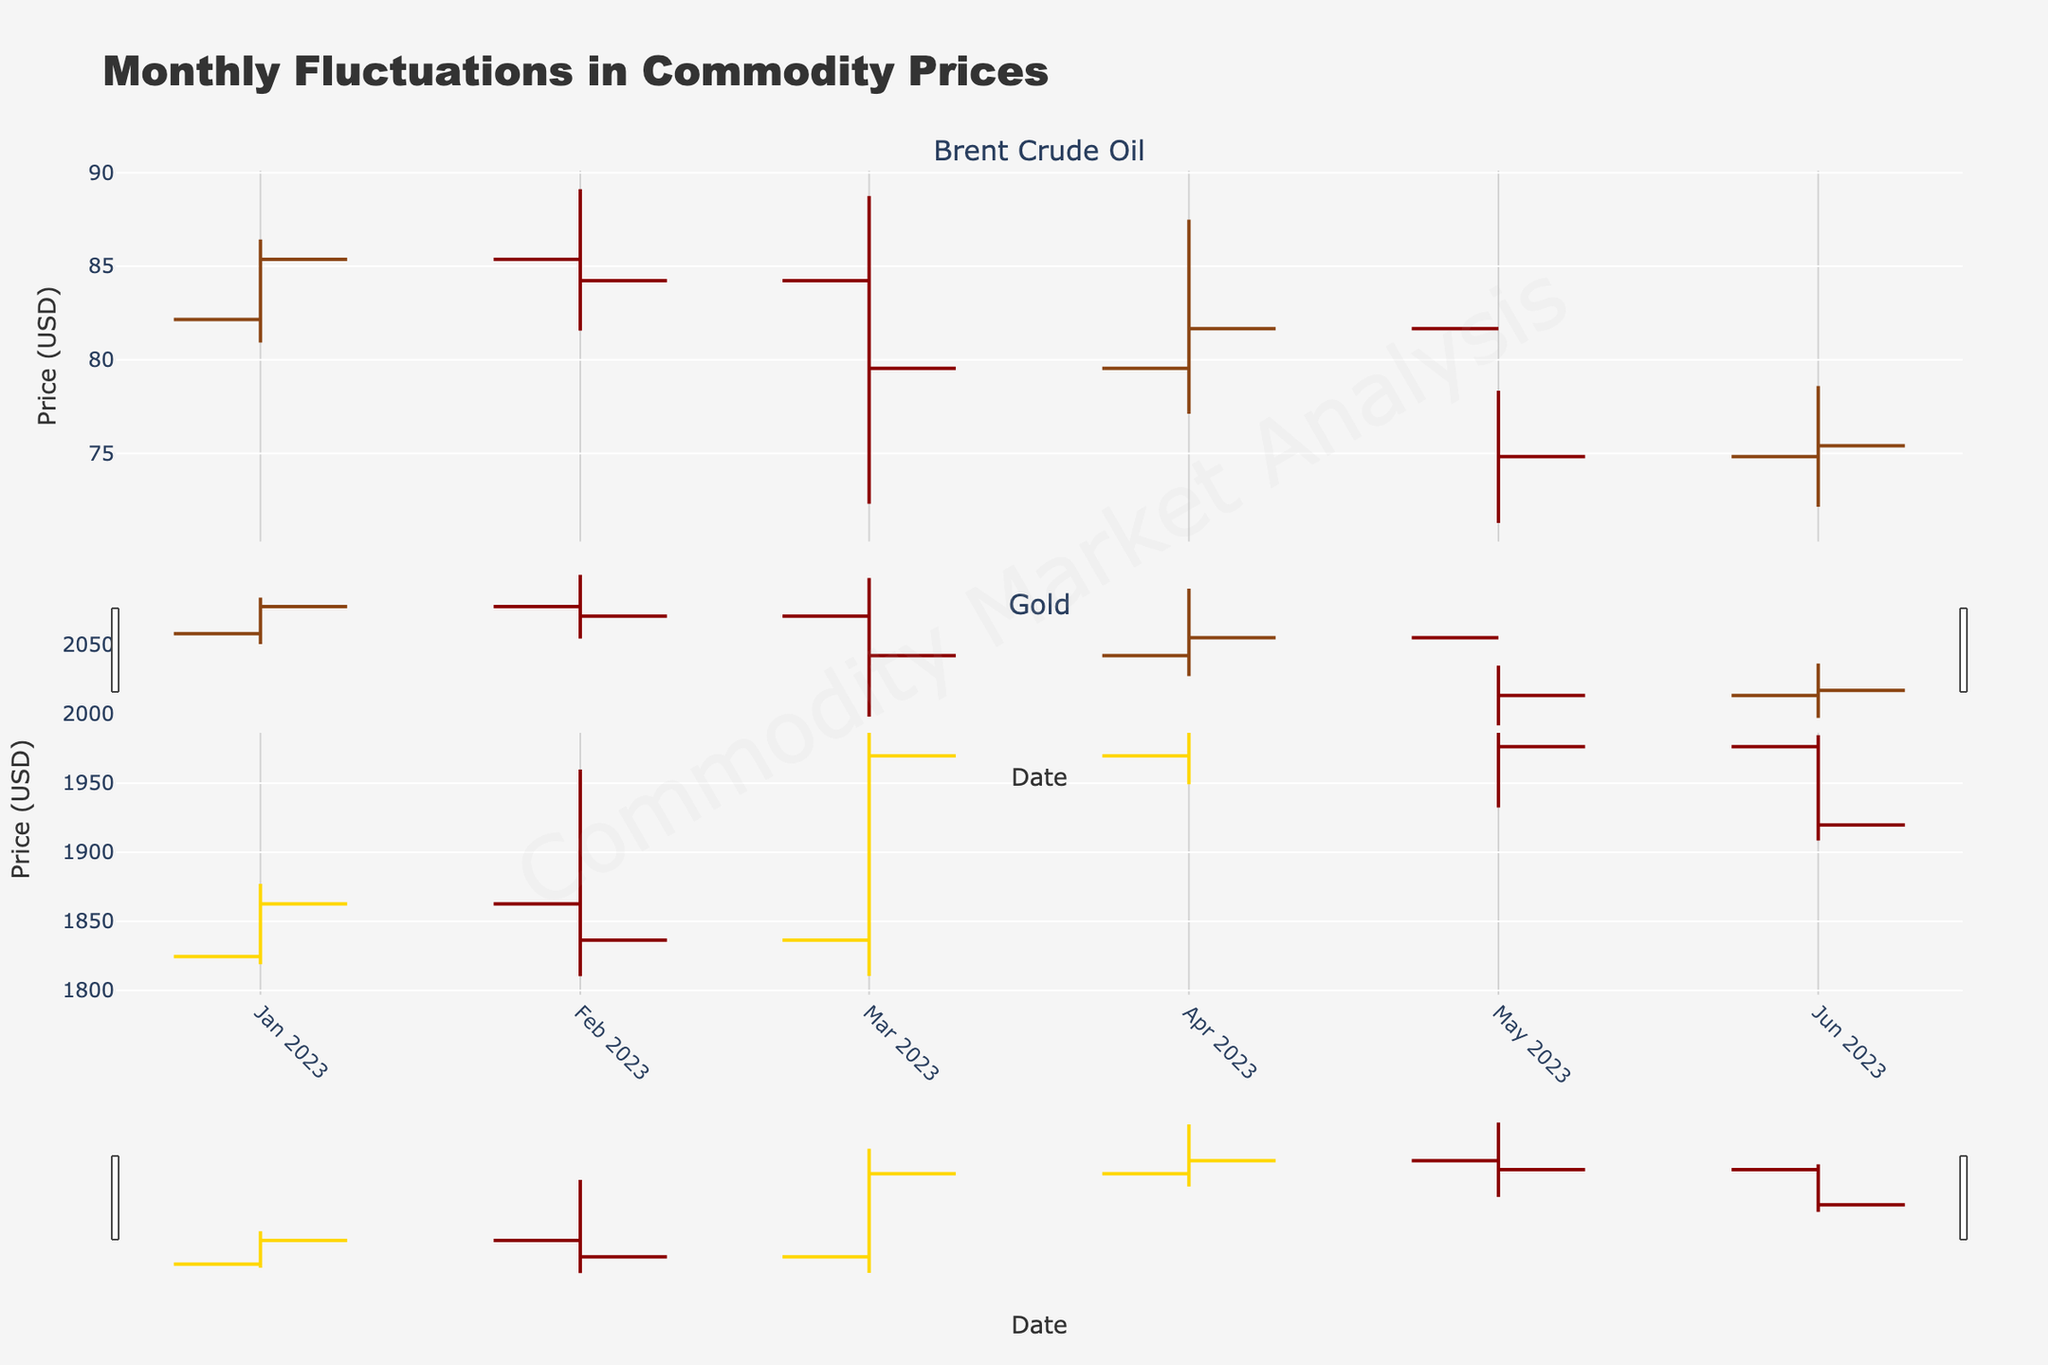What is the title of the figure? The title of the figure is typically located at the top center and is used to summarize the content of the chart. In this case, the title reads "Monthly Fluctuations in Commodity Prices."
Answer: Monthly Fluctuations in Commodity Prices Which commodity had the highest closing price in March 2023? To find the highest closing price in March 2023, look at the OHLC chart for both commodities for the month of March. The closing prices are 79.54 for Brent Crude Oil and 1969.80 for Gold. Thus, Gold had the highest closing price.
Answer: Gold How does the opening price of Brent Crude Oil in April 2023 compare to its closing price in the same month? For April 2023, locate Brent Crude Oil data points. The opening price is 79.54 and the closing price is 81.66. Comparing these, the closing price is higher than the opening price by 2.12 USD.
Answer: Higher by 2.12 USD What is the general trend of Gold prices over the six months shown? Look at the 'Close' prices of Gold from January 2023 to June 2023: 1862.70, 1836.40, 1969.80, 1990.50, 1976.30, 1919.80. Generally, the prices increase from January to April, then they moderate back down by June.
Answer: Increasing then moderating Which commodity showed a greater range of price fluctuations in May 2023? For May 2023, calculate the range (High - Low) for both commodities. Brent Crude Oil has a range of 78.35 - 71.28 = 7.07 USD, and Gold has a range of 2051.80 - 1932.40 = 119.40 USD. Therefore, Gold showed a greater range.
Answer: Gold Between January and June 2023, which commodity's closing price decreased more overall? Calculate the difference between the closing price in January and June for each commodity. For Brent Crude Oil, it's 85.37 - 75.41 = 9.96 USD. For Gold, it's 1862.70 - 1919.80 = -57.10 USD. While Brent Crude Oil dropped by $9.96, Gold actually increased by $57.10. Therefore, Brent Crude Oil decreased more.
Answer: Brent Crude Oil What is the color representing Brent Crude Oil's increasing prices? The color of the lines indicating increasing prices specifically for Brent Crude Oil can be identified by looking at the chart legend. This is depicted in a brown-like color according to the custom colors used.
Answer: Brown Was there any month when Brent Crude Oil had an all-time low within this period? Look at the 'Low' values for Brent Crude Oil across the months. The lowest value appears in March 2023 with a 'Low' of 72.30 USD. Cross-check the values to confirm.
Answer: Yes, in March 2023 In which month did Gold have its highest opening price and what was this price? Refer to the 'Open' prices for Gold across the provided months. The highest is found in April 2023 with an opening price of 1969.80 USD. Verify this by reviewing each month's 'Open' values for Gold.
Answer: April 2023, 1969.80 USD 